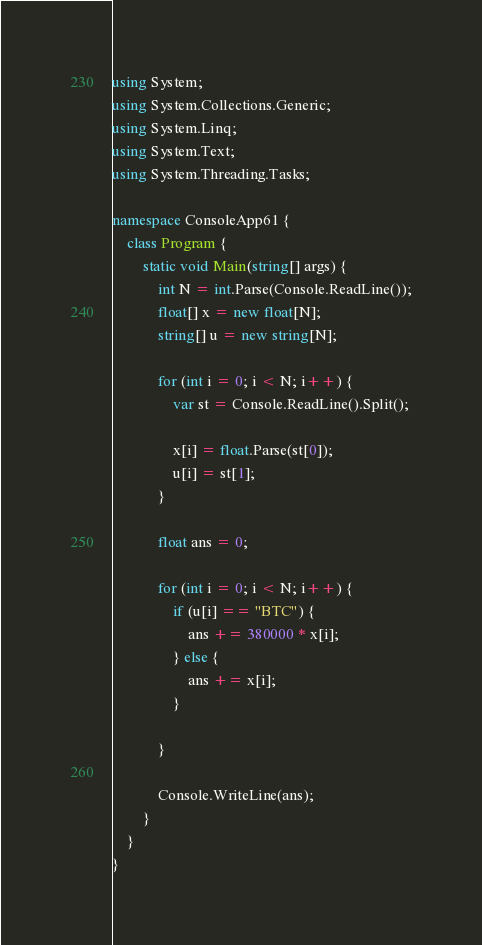<code> <loc_0><loc_0><loc_500><loc_500><_C#_>using System;
using System.Collections.Generic;
using System.Linq;
using System.Text;
using System.Threading.Tasks;

namespace ConsoleApp61 {
    class Program {
        static void Main(string[] args) {
            int N = int.Parse(Console.ReadLine());
            float[] x = new float[N];
            string[] u = new string[N];

            for (int i = 0; i < N; i++) {
                var st = Console.ReadLine().Split();

                x[i] = float.Parse(st[0]);
                u[i] = st[1];
            }

            float ans = 0;

            for (int i = 0; i < N; i++) {
                if (u[i] == "BTC") {
                    ans += 380000 * x[i];
                } else {
                    ans += x[i];
                }

            }

            Console.WriteLine(ans);
        }
    }
}
</code> 